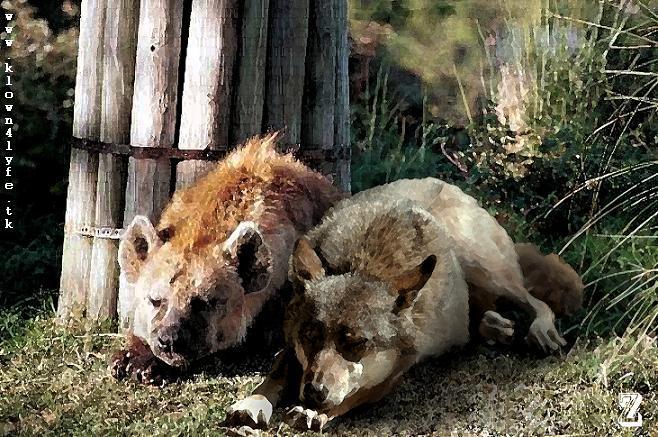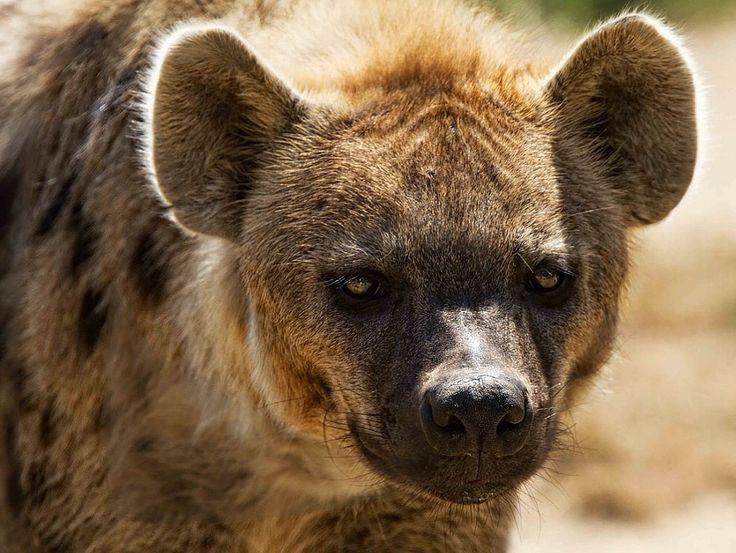The first image is the image on the left, the second image is the image on the right. Considering the images on both sides, is "One standing animal with a black nose is looking forward in the right image." valid? Answer yes or no. Yes. The first image is the image on the left, the second image is the image on the right. Evaluate the accuracy of this statement regarding the images: "The image on the left shows 2 animals both looking in the same direction.". Is it true? Answer yes or no. Yes. 